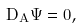Convert formula to latex. <formula><loc_0><loc_0><loc_500><loc_500>D _ { \AA A } \Psi = 0 ,</formula> 